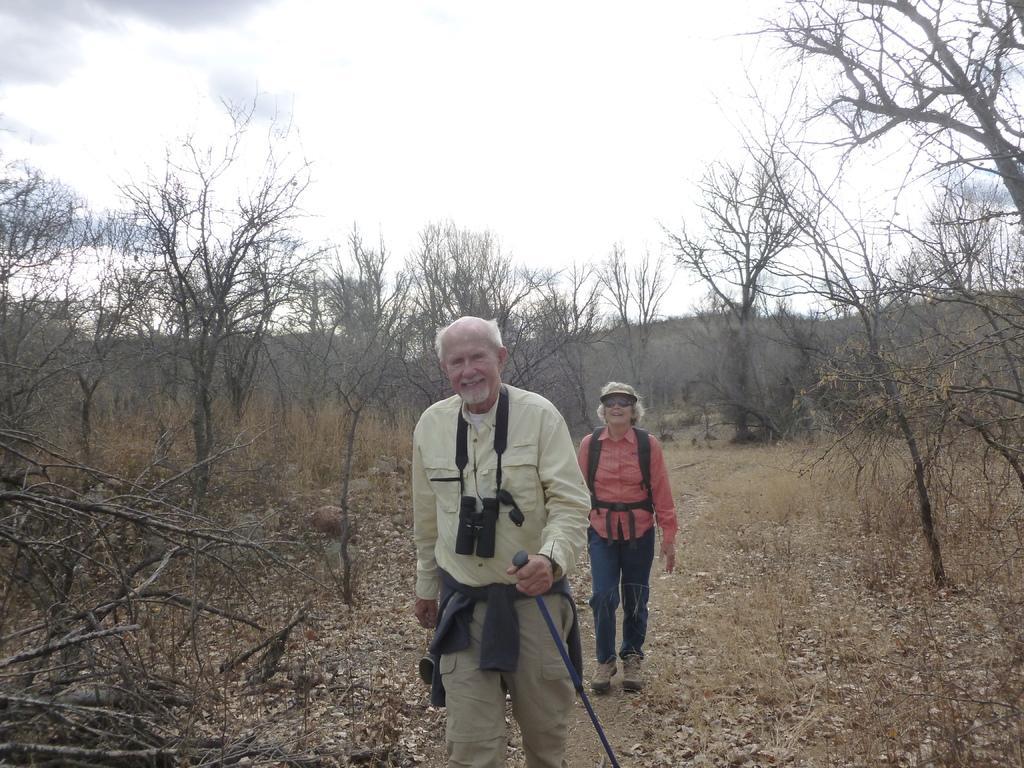In one or two sentences, can you explain what this image depicts? In this image, I can see trees, grass and two persons standing. In the background, there is the sky. 